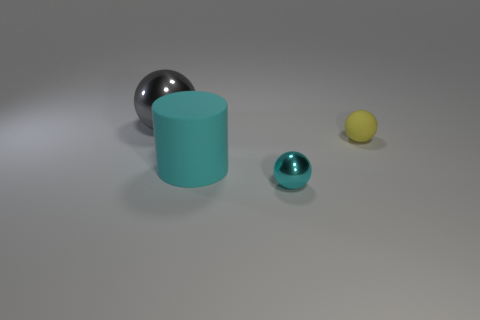Subtract 1 balls. How many balls are left? 2 Add 2 cyan rubber cylinders. How many objects exist? 6 Subtract all balls. How many objects are left? 1 Add 3 gray metallic spheres. How many gray metallic spheres are left? 4 Add 2 large cyan cylinders. How many large cyan cylinders exist? 3 Subtract 1 gray balls. How many objects are left? 3 Subtract all metal spheres. Subtract all tiny purple things. How many objects are left? 2 